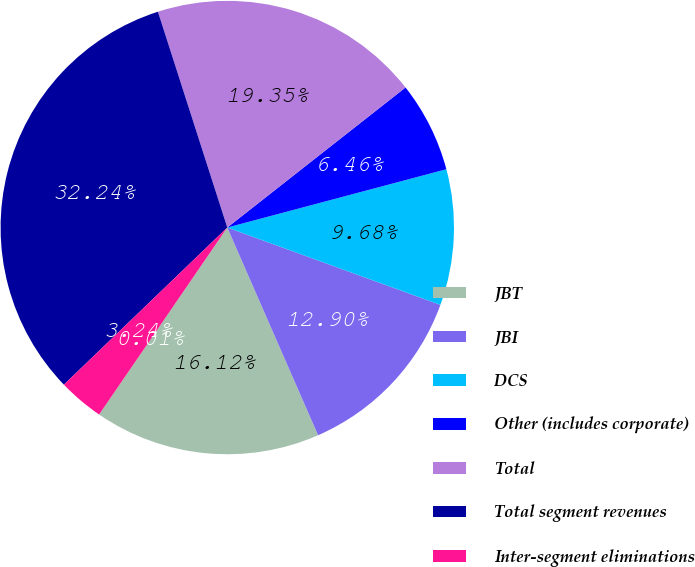Convert chart to OTSL. <chart><loc_0><loc_0><loc_500><loc_500><pie_chart><fcel>JBT<fcel>JBI<fcel>DCS<fcel>Other (includes corporate)<fcel>Total<fcel>Total segment revenues<fcel>Inter-segment eliminations<fcel>Other<nl><fcel>16.12%<fcel>12.9%<fcel>9.68%<fcel>6.46%<fcel>19.35%<fcel>32.24%<fcel>3.24%<fcel>0.01%<nl></chart> 